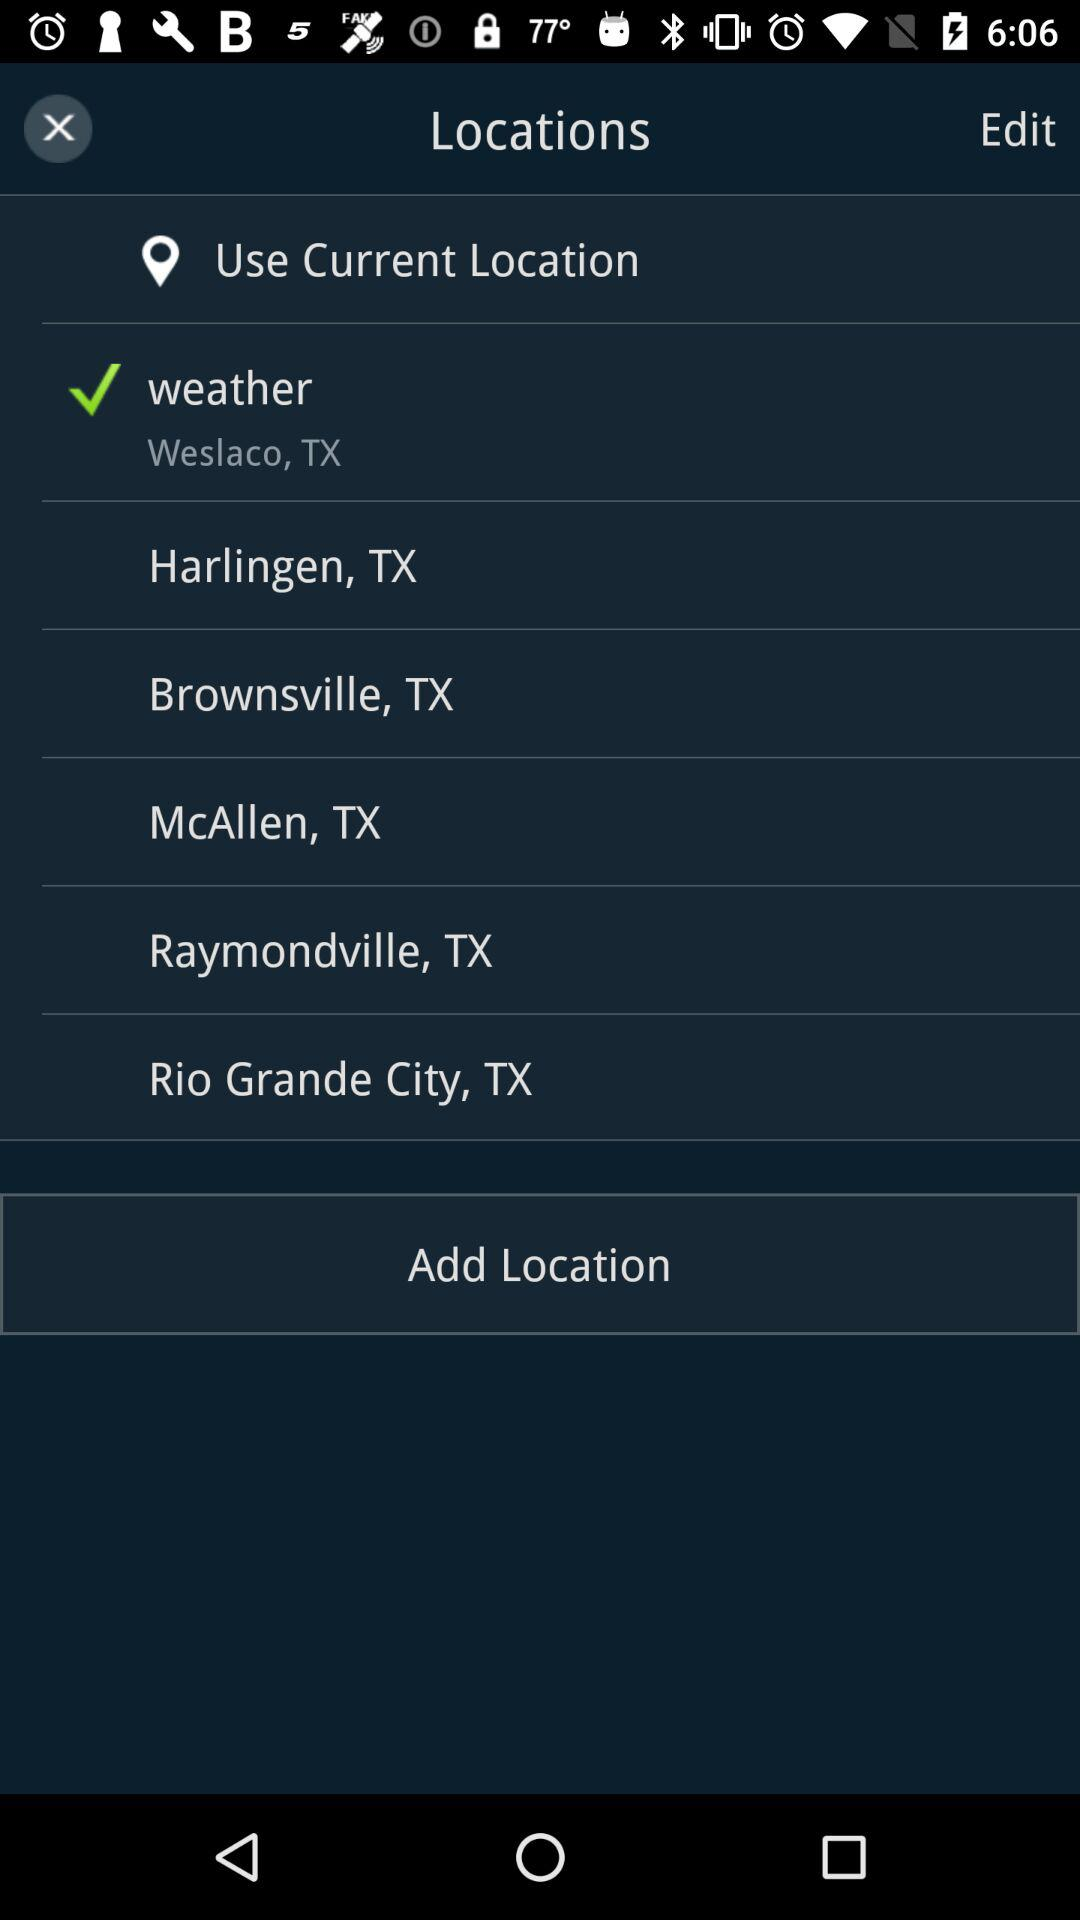How many locations have been added?
Answer the question using a single word or phrase. 6 